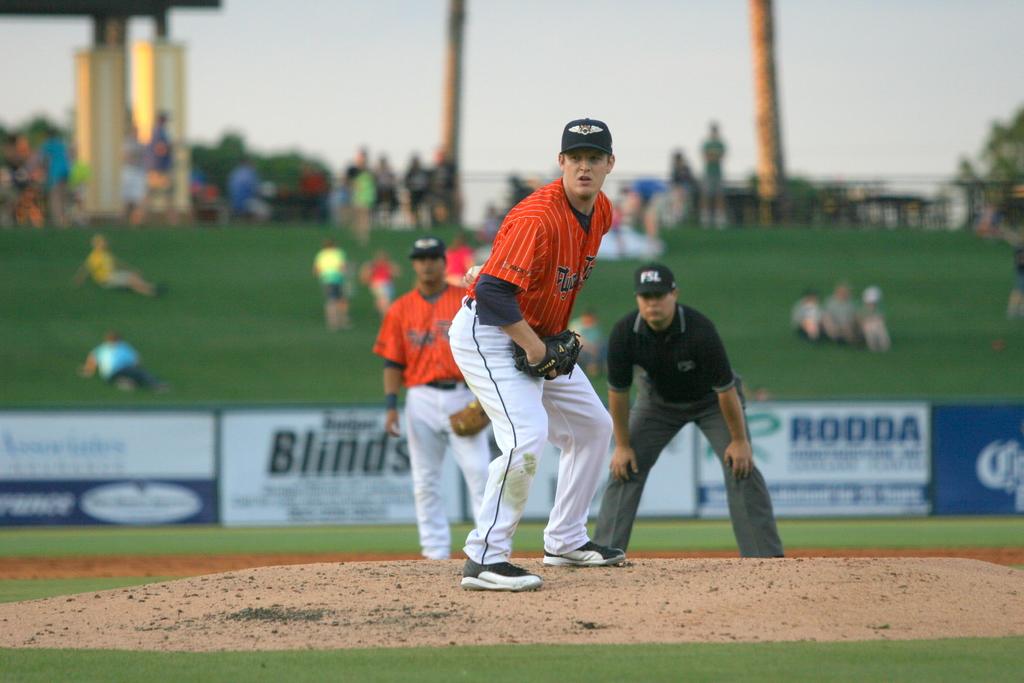What is an advertisement here?
Keep it short and to the point. Rodda. What had does the pitcher throw with?
Keep it short and to the point. Left. 